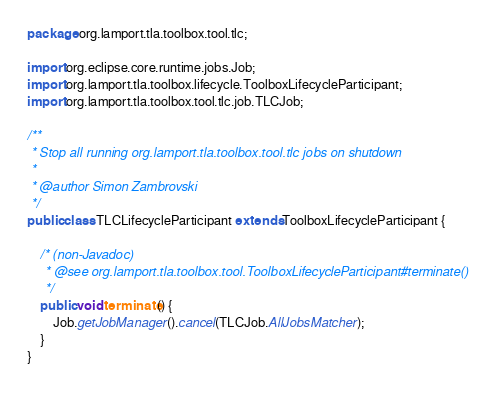<code> <loc_0><loc_0><loc_500><loc_500><_Java_>package org.lamport.tla.toolbox.tool.tlc;

import org.eclipse.core.runtime.jobs.Job;
import org.lamport.tla.toolbox.lifecycle.ToolboxLifecycleParticipant;
import org.lamport.tla.toolbox.tool.tlc.job.TLCJob;

/**
 * Stop all running org.lamport.tla.toolbox.tool.tlc jobs on shutdown
 * 
 * @author Simon Zambrovski
 */
public class TLCLifecycleParticipant extends ToolboxLifecycleParticipant {

	/* (non-Javadoc)
	 * @see org.lamport.tla.toolbox.tool.ToolboxLifecycleParticipant#terminate()
	 */
	public void terminate() {
		Job.getJobManager().cancel(TLCJob.AllJobsMatcher);
	}
}
</code> 